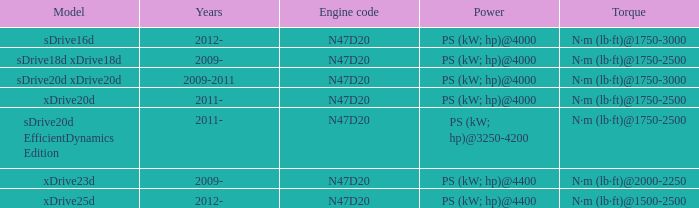What years did the sdrive16d model have a Torque of n·m (lb·ft)@1750-3000? 2012-. 